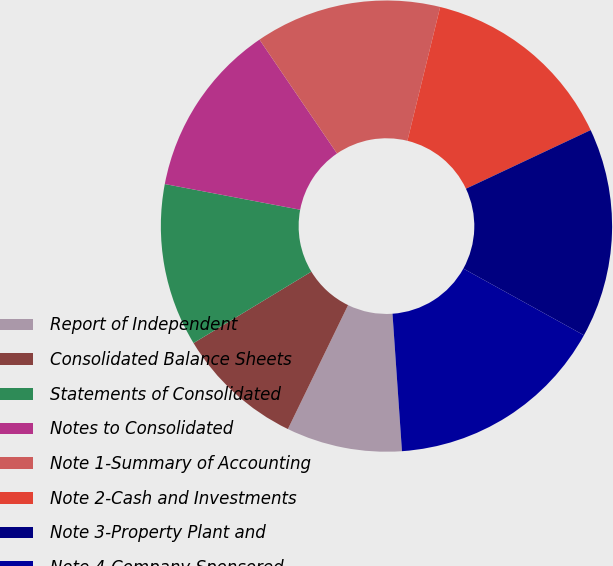Convert chart. <chart><loc_0><loc_0><loc_500><loc_500><pie_chart><fcel>Report of Independent<fcel>Consolidated Balance Sheets<fcel>Statements of Consolidated<fcel>Notes to Consolidated<fcel>Note 1-Summary of Accounting<fcel>Note 2-Cash and Investments<fcel>Note 3-Property Plant and<fcel>Note 4-Company-Sponsored<nl><fcel>8.29%<fcel>9.13%<fcel>11.66%<fcel>12.5%<fcel>13.34%<fcel>14.18%<fcel>15.03%<fcel>15.87%<nl></chart> 